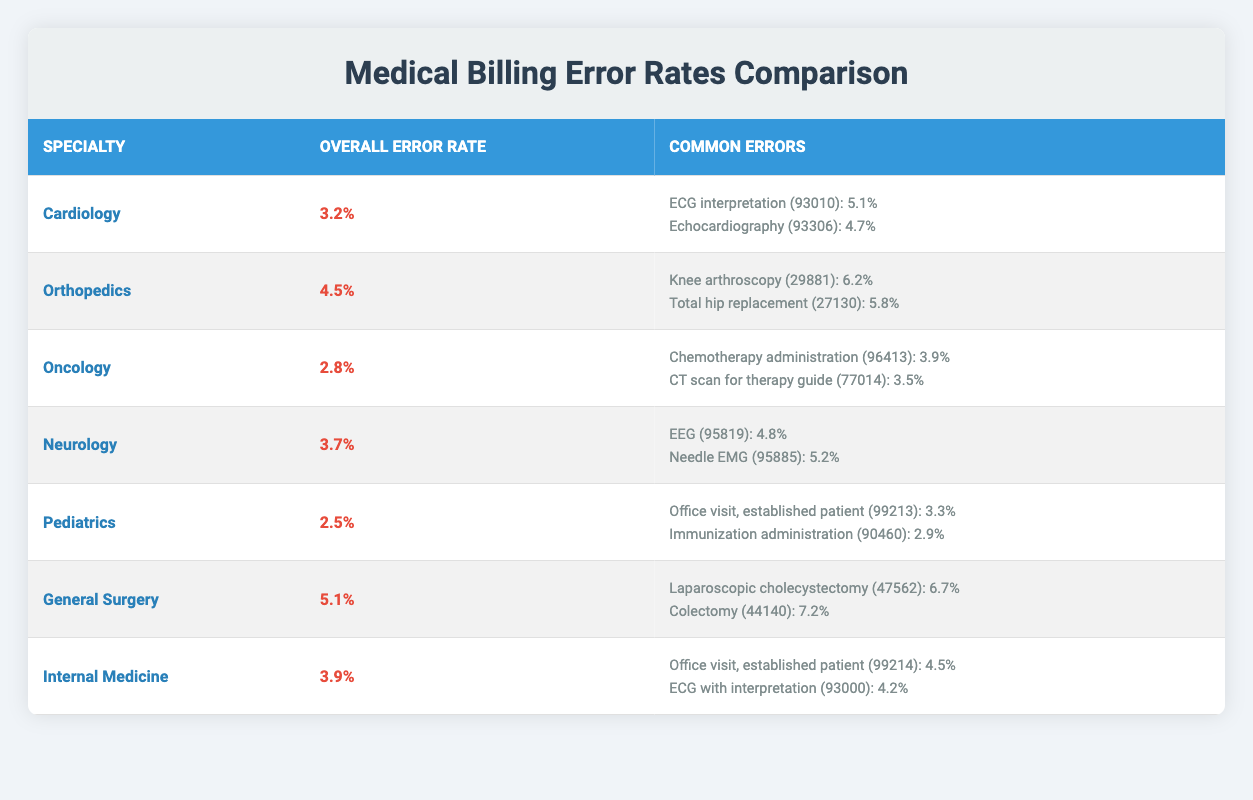What is the overall error rate for Orthopedics? The overall error rate for Orthopedics is listed directly in the table under the 'Overall Error Rate' column, which states 4.5%.
Answer: 4.5% Which specialty has the highest overall error rate? By examining the 'Overall Error Rate' column, General Surgery has the highest overall error rate at 5.1%.
Answer: General Surgery What are the common errors for Internal Medicine? The common errors for Internal Medicine are listed in the corresponding row, which includes "Office visit, established patient (99214): 4.5%" and "ECG with interpretation (93000): 4.2%."
Answer: Office visit, established patient (99214): 4.5%, ECG with interpretation (93000): 4.2% Is the error rate for Pediatrics lower than that for Oncology? The error rate for Pediatrics is 2.5%, and for Oncology, it is 2.8%. Since 2.5% is less than 2.8%, the statement is true.
Answer: Yes What is the average overall error rate of all specialties listed? We add the overall error rates: (3.2 + 4.5 + 2.8 + 3.7 + 2.5 + 5.1 + 3.9) = 25.7. There are 7 specialties, so we divide by 7: 25.7 / 7 = 3.671.
Answer: 3.671 Which common error in General Surgery has the highest error rate? In the General Surgery section, the common errors are "Laparoscopic cholecystectomy (47562): 6.7%" and "Colectomy (44140): 7.2%." Colectomy has the highest error rate of 7.2%.
Answer: Colectomy (44140): 7.2% Does Cardiology have any common errors with an error rate above 5%? The common errors for Cardiology are "ECG interpretation (93010): 5.1%" and "Echocardiography (93306): 4.7%." Only ECG interpretation has an error rate above 5%, so the statement is true.
Answer: Yes How many common errors are listed for Neurology and what are they? Neurology lists two common errors: "EEG (95819): 4.8%" and "Needle EMG (95885): 5.2%." Therefore, there are two common errors listed.
Answer: Two common errors: EEG (95819): 4.8%, Needle EMG (95885): 5.2% 